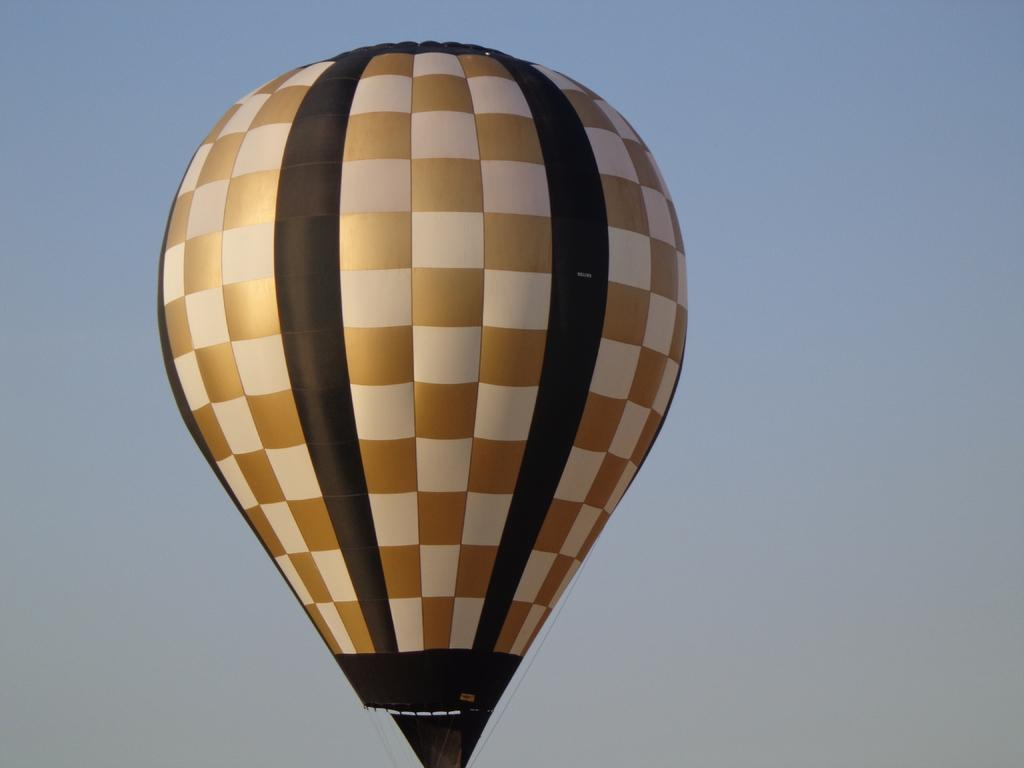What is the main subject of the image? The main subject of the image is a gas balloon. Where is the gas balloon located in the image? The gas balloon is in the air. What flavor of ice cream is being served in the gas balloon? There is no ice cream or any serving being depicted in the image; it only features a gas balloon in the air. 